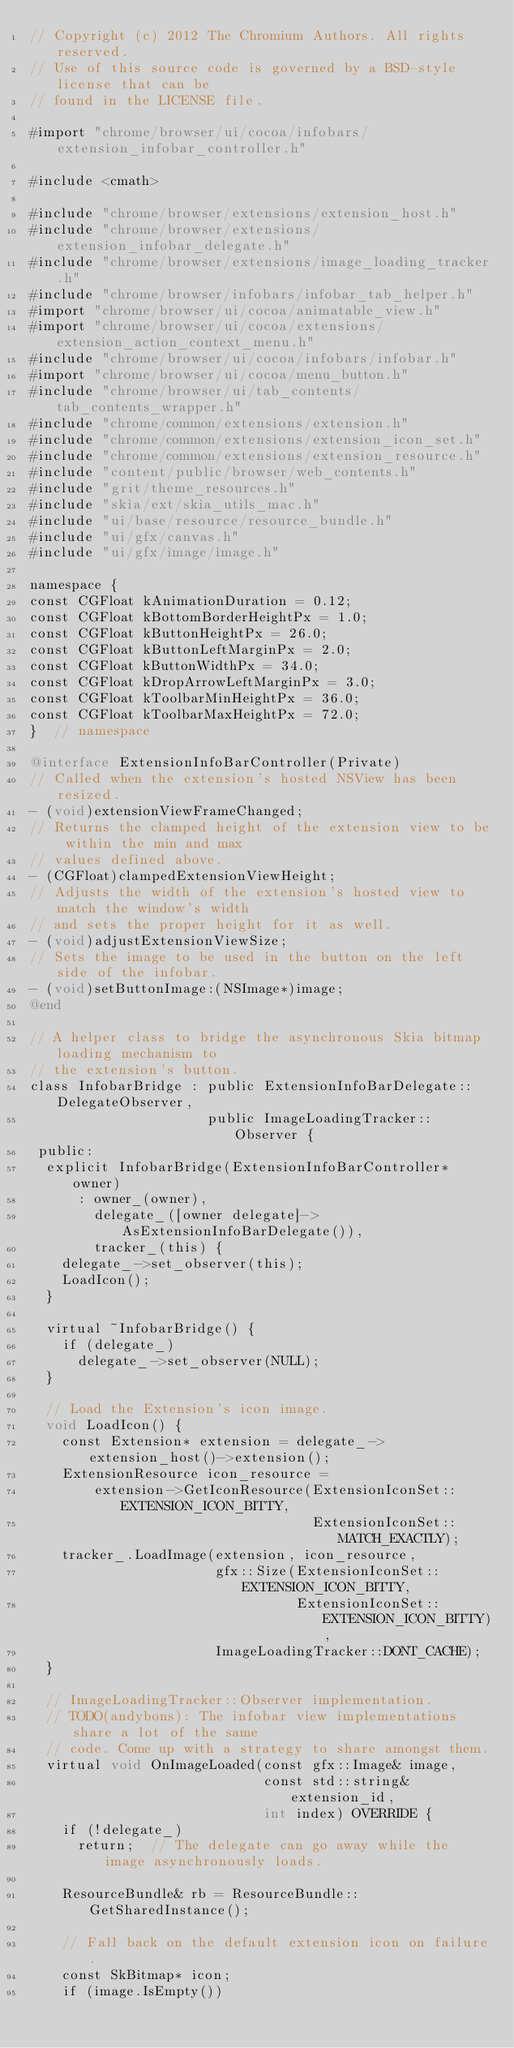<code> <loc_0><loc_0><loc_500><loc_500><_ObjectiveC_>// Copyright (c) 2012 The Chromium Authors. All rights reserved.
// Use of this source code is governed by a BSD-style license that can be
// found in the LICENSE file.

#import "chrome/browser/ui/cocoa/infobars/extension_infobar_controller.h"

#include <cmath>

#include "chrome/browser/extensions/extension_host.h"
#include "chrome/browser/extensions/extension_infobar_delegate.h"
#include "chrome/browser/extensions/image_loading_tracker.h"
#include "chrome/browser/infobars/infobar_tab_helper.h"
#import "chrome/browser/ui/cocoa/animatable_view.h"
#import "chrome/browser/ui/cocoa/extensions/extension_action_context_menu.h"
#include "chrome/browser/ui/cocoa/infobars/infobar.h"
#import "chrome/browser/ui/cocoa/menu_button.h"
#include "chrome/browser/ui/tab_contents/tab_contents_wrapper.h"
#include "chrome/common/extensions/extension.h"
#include "chrome/common/extensions/extension_icon_set.h"
#include "chrome/common/extensions/extension_resource.h"
#include "content/public/browser/web_contents.h"
#include "grit/theme_resources.h"
#include "skia/ext/skia_utils_mac.h"
#include "ui/base/resource/resource_bundle.h"
#include "ui/gfx/canvas.h"
#include "ui/gfx/image/image.h"

namespace {
const CGFloat kAnimationDuration = 0.12;
const CGFloat kBottomBorderHeightPx = 1.0;
const CGFloat kButtonHeightPx = 26.0;
const CGFloat kButtonLeftMarginPx = 2.0;
const CGFloat kButtonWidthPx = 34.0;
const CGFloat kDropArrowLeftMarginPx = 3.0;
const CGFloat kToolbarMinHeightPx = 36.0;
const CGFloat kToolbarMaxHeightPx = 72.0;
}  // namespace

@interface ExtensionInfoBarController(Private)
// Called when the extension's hosted NSView has been resized.
- (void)extensionViewFrameChanged;
// Returns the clamped height of the extension view to be within the min and max
// values defined above.
- (CGFloat)clampedExtensionViewHeight;
// Adjusts the width of the extension's hosted view to match the window's width
// and sets the proper height for it as well.
- (void)adjustExtensionViewSize;
// Sets the image to be used in the button on the left side of the infobar.
- (void)setButtonImage:(NSImage*)image;
@end

// A helper class to bridge the asynchronous Skia bitmap loading mechanism to
// the extension's button.
class InfobarBridge : public ExtensionInfoBarDelegate::DelegateObserver,
                      public ImageLoadingTracker::Observer {
 public:
  explicit InfobarBridge(ExtensionInfoBarController* owner)
      : owner_(owner),
        delegate_([owner delegate]->AsExtensionInfoBarDelegate()),
        tracker_(this) {
    delegate_->set_observer(this);
    LoadIcon();
  }

  virtual ~InfobarBridge() {
    if (delegate_)
      delegate_->set_observer(NULL);
  }

  // Load the Extension's icon image.
  void LoadIcon() {
    const Extension* extension = delegate_->extension_host()->extension();
    ExtensionResource icon_resource =
        extension->GetIconResource(ExtensionIconSet::EXTENSION_ICON_BITTY,
                                   ExtensionIconSet::MATCH_EXACTLY);
    tracker_.LoadImage(extension, icon_resource,
                       gfx::Size(ExtensionIconSet::EXTENSION_ICON_BITTY,
                                 ExtensionIconSet::EXTENSION_ICON_BITTY),
                       ImageLoadingTracker::DONT_CACHE);
  }

  // ImageLoadingTracker::Observer implementation.
  // TODO(andybons): The infobar view implementations share a lot of the same
  // code. Come up with a strategy to share amongst them.
  virtual void OnImageLoaded(const gfx::Image& image,
                             const std::string& extension_id,
                             int index) OVERRIDE {
    if (!delegate_)
      return;  // The delegate can go away while the image asynchronously loads.

    ResourceBundle& rb = ResourceBundle::GetSharedInstance();

    // Fall back on the default extension icon on failure.
    const SkBitmap* icon;
    if (image.IsEmpty())</code> 